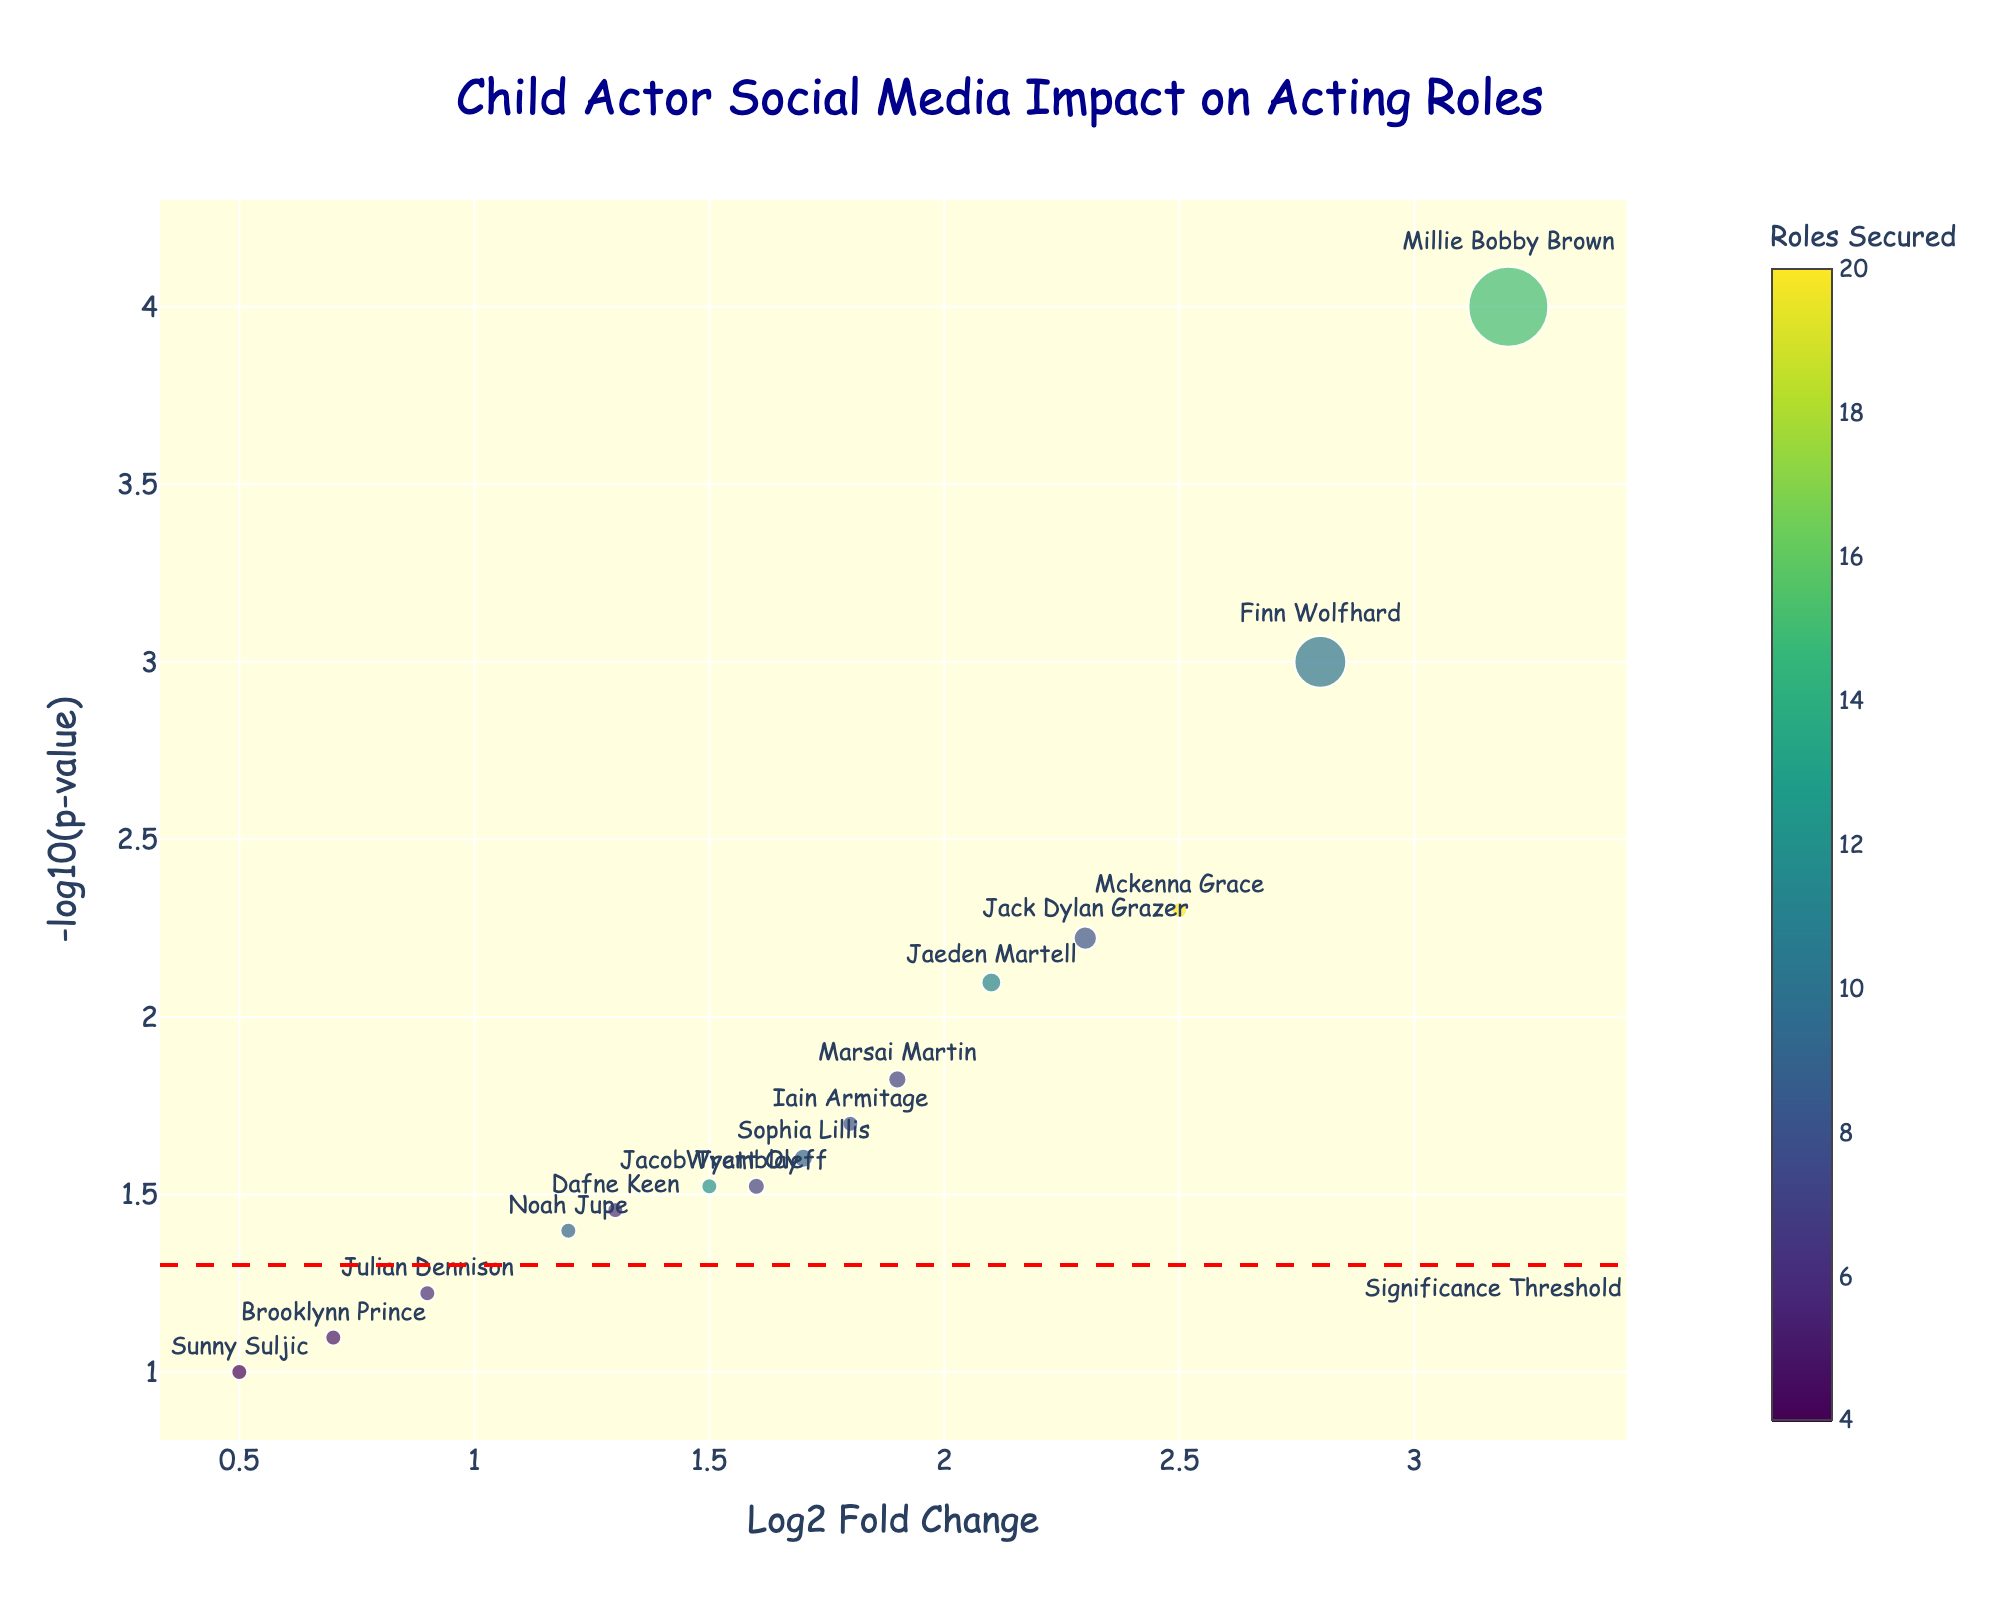What is the title of the plot? The title of the plot is usually found at the top and is often larger in font size and a different color. It helps you understand the main topic of the graph.
Answer: Child Actor Social Media Impact on Acting Roles How many child actors are displayed in the plot? To find out the number of child actors, you need to count the number of different marker points in the plot, each labeled with an actor's name.
Answer: 15 How are the colors of the points determined? The legend or color scale indicates that the colors are based on the number of acting roles secured by each actor. This information is typically shown as a gradient or specific colors next to a numeric scale.
Answer: By the number of acting roles secured What does the size of each point represent? The size of each point usually maps to another quantity of interest. In this case, it is proportional to the number of social media followers each actor has, divided by a million for scaling.
Answer: Number of social media followers Which child actor has the highest Log2 Fold Change (Log2FC)? To find the actor with the highest Log2FC, you look for the point farthest to the right on the x-axis. Reading the label of this point will give you the answer.
Answer: Millie Bobby Brown How many child actors have a p-value that surpasses the significance threshold? The significance threshold is typically indicated by a line on the plot. You check how many points lie above this threshold line, which is shown at -log10(0.05).
Answer: 11 Which child actor has the lowest p-value, and what is that value? To find the actor with the lowest p-value, look for the point that is the highest on the y-axis and read its label. Then convert the -log10(p-value) back to the p-value itself.
Answer: Millie Bobby Brown, 0.0001 What does the red dashed line represent in the plot? A red dashed line usually indicates a threshold or critical value. In this case, it signifies the significance threshold for the p-value, helping to distinguish statistically significant points.
Answer: Significance threshold Compare the numbers of acting roles secured by Millie Bobby Brown and Mckenna Grace. Who has secured more roles? You look at the color bar and the text label next to each point. Millie Bobby Brown's point will show the value compared to that of Mckenna Grace's.
Answer: Mckenna Grace Between Julian Dennison and Brooklynn Prince, who has a higher Log2FC and by how much? Find these two actors' points on the x-axis and compare their Log2FC values. Subtract the lower value from the higher value to find the difference.
Answer: Julian Dennison by 0.2 